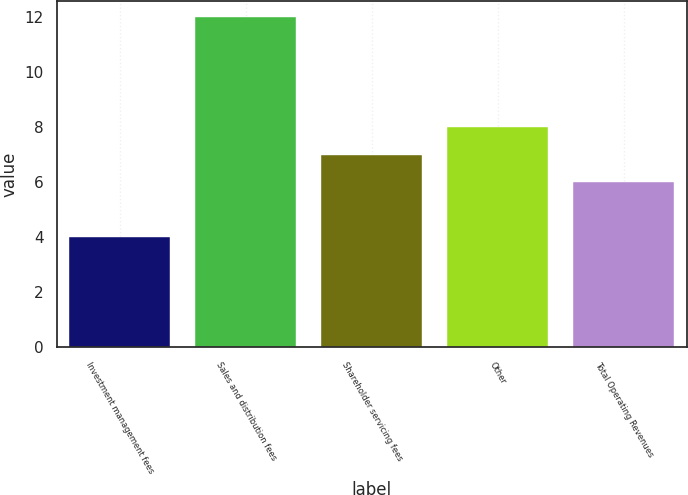Convert chart. <chart><loc_0><loc_0><loc_500><loc_500><bar_chart><fcel>Investment management fees<fcel>Sales and distribution fees<fcel>Shareholder servicing fees<fcel>Other<fcel>Total Operating Revenues<nl><fcel>4<fcel>12<fcel>7<fcel>8<fcel>6<nl></chart> 